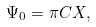<formula> <loc_0><loc_0><loc_500><loc_500>\Psi _ { 0 } = \pi C X ,</formula> 